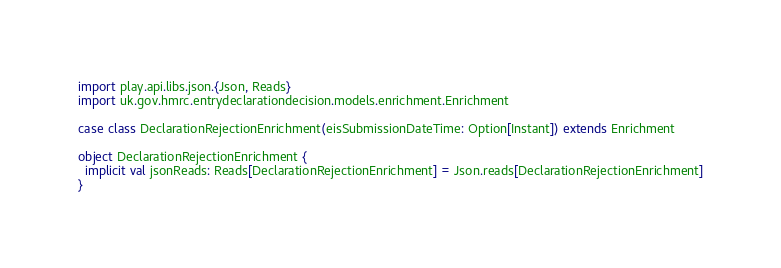Convert code to text. <code><loc_0><loc_0><loc_500><loc_500><_Scala_>import play.api.libs.json.{Json, Reads}
import uk.gov.hmrc.entrydeclarationdecision.models.enrichment.Enrichment

case class DeclarationRejectionEnrichment(eisSubmissionDateTime: Option[Instant]) extends Enrichment

object DeclarationRejectionEnrichment {
  implicit val jsonReads: Reads[DeclarationRejectionEnrichment] = Json.reads[DeclarationRejectionEnrichment]
}
</code> 